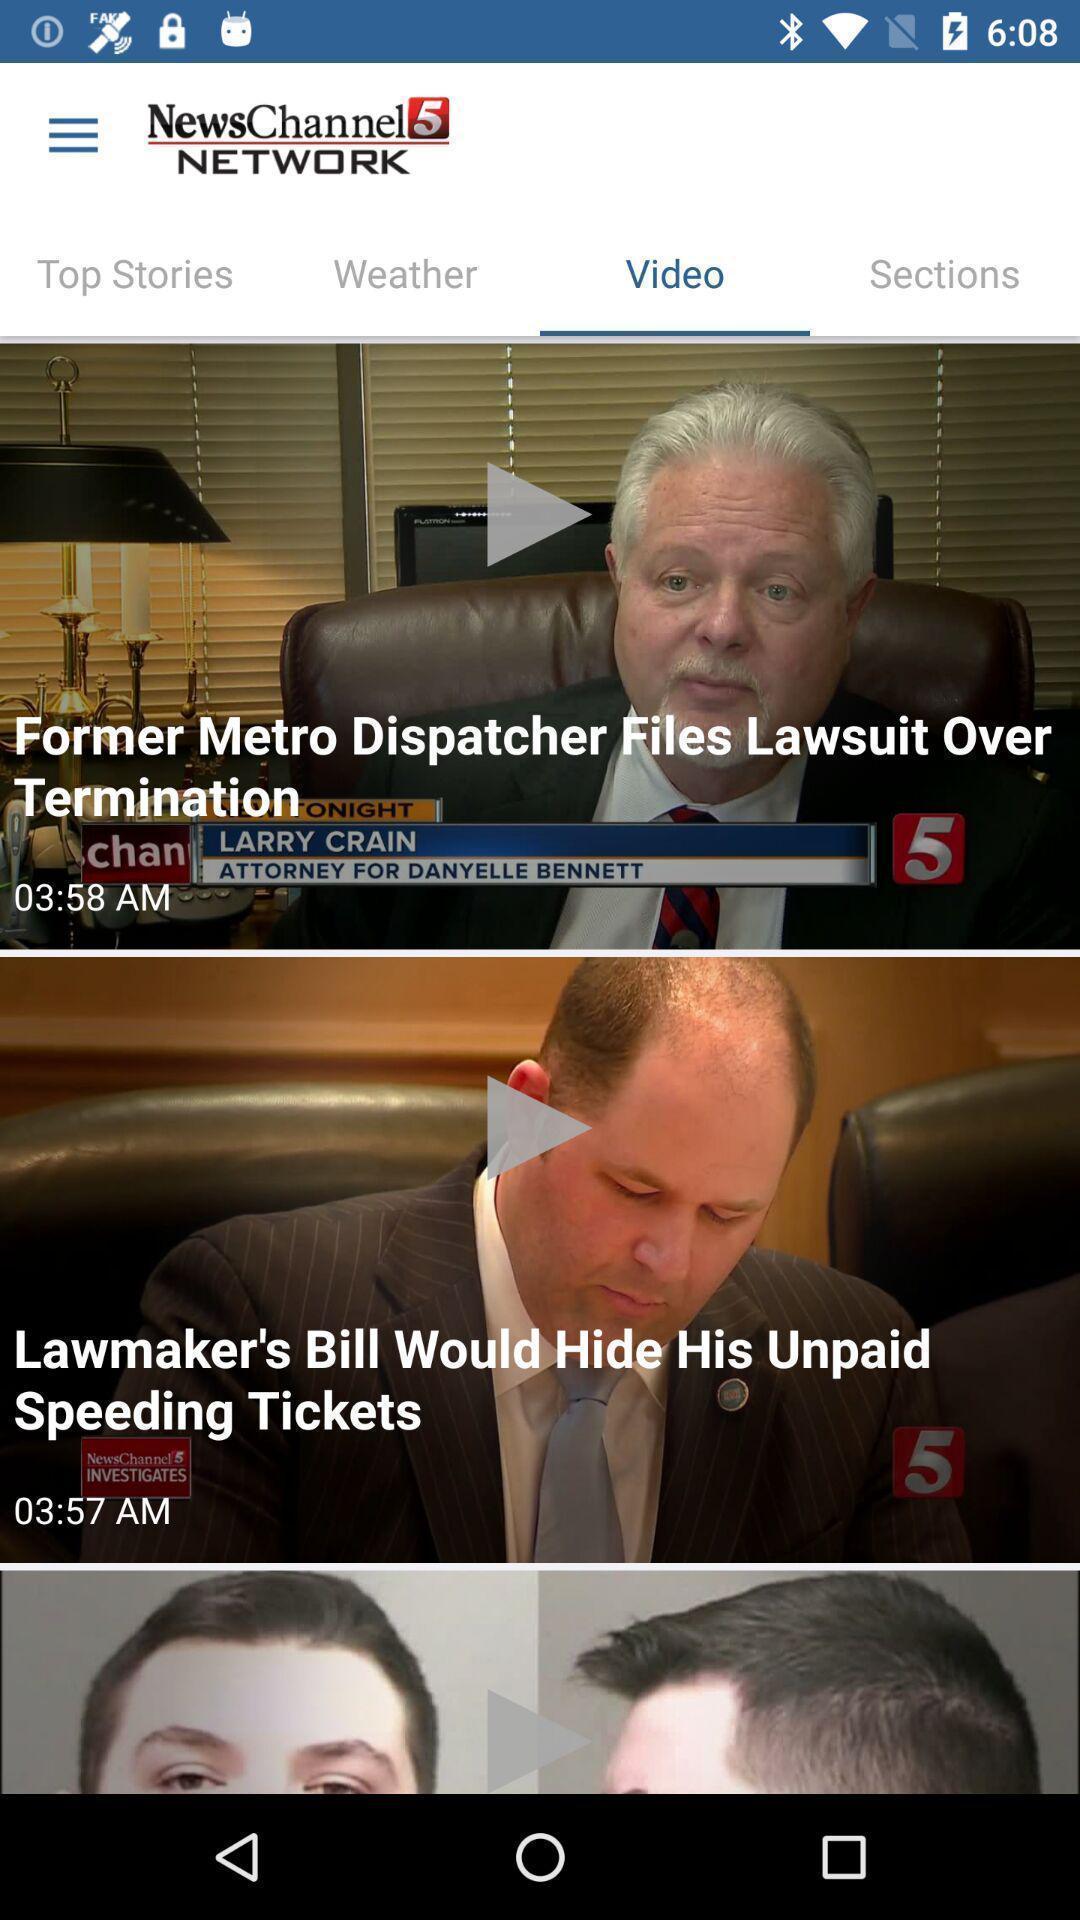Summarize the information in this screenshot. Page with news videos in a news app. 